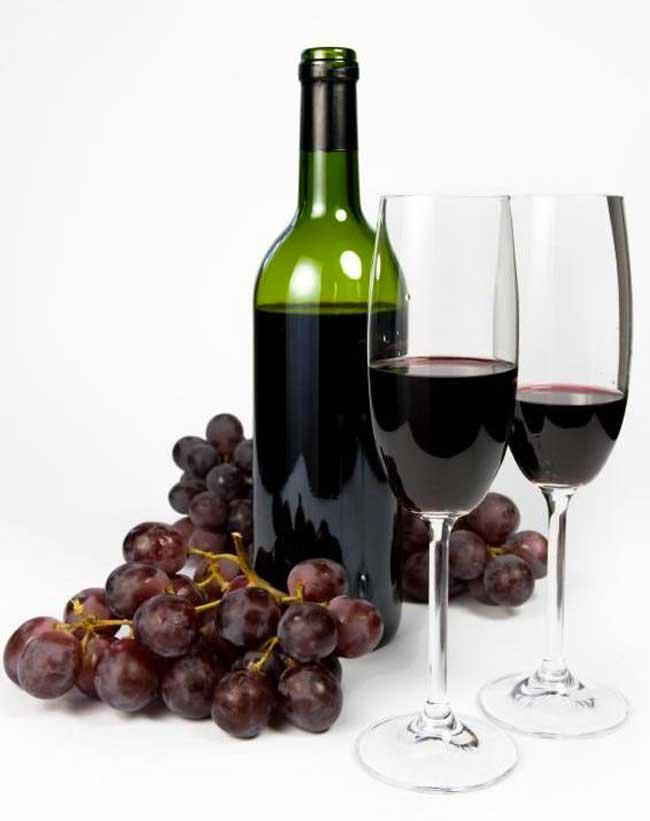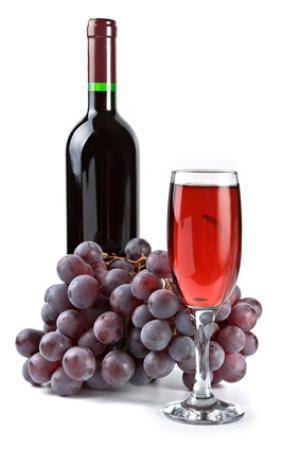The first image is the image on the left, the second image is the image on the right. For the images displayed, is the sentence "One of the bottles of wine is green and sits near a pile of grapes." factually correct? Answer yes or no. Yes. The first image is the image on the left, the second image is the image on the right. Given the left and right images, does the statement "There is exactly one wineglass sitting on the left side of the bottle in the image on the left." hold true? Answer yes or no. No. 